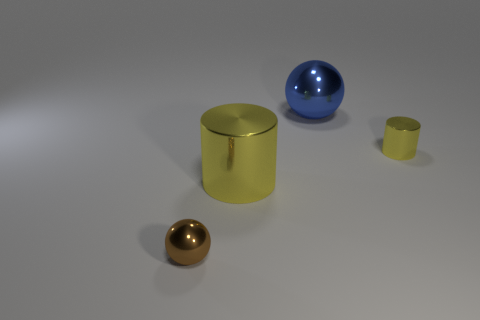Add 2 big metal things. How many objects exist? 6 Subtract 0 yellow spheres. How many objects are left? 4 Subtract all metal cylinders. Subtract all brown shiny balls. How many objects are left? 1 Add 2 small brown metallic things. How many small brown metallic things are left? 3 Add 3 large green shiny cylinders. How many large green shiny cylinders exist? 3 